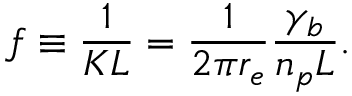<formula> <loc_0><loc_0><loc_500><loc_500>f \equiv \frac { 1 } { K L } = \frac { 1 } { 2 \pi r _ { e } } \frac { \gamma _ { b } } { n _ { p } L } .</formula> 